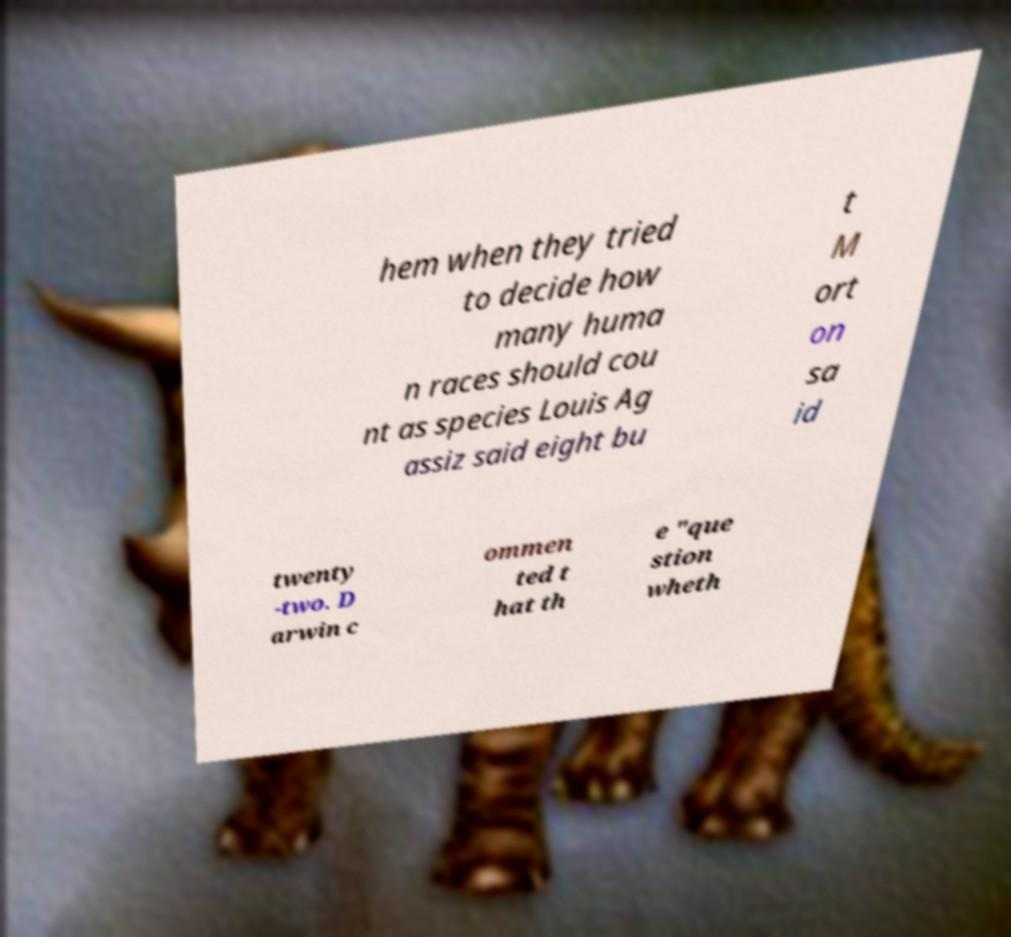For documentation purposes, I need the text within this image transcribed. Could you provide that? hem when they tried to decide how many huma n races should cou nt as species Louis Ag assiz said eight bu t M ort on sa id twenty -two. D arwin c ommen ted t hat th e "que stion wheth 